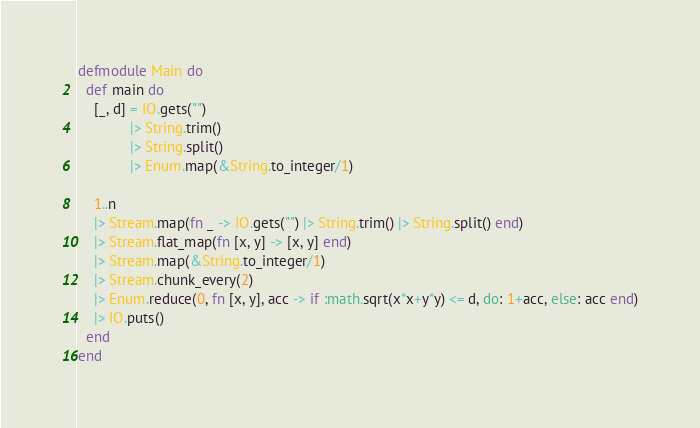<code> <loc_0><loc_0><loc_500><loc_500><_Elixir_>defmodule Main do
  def main do
    [_, d] = IO.gets("")
             |> String.trim()
             |> String.split()
             |> Enum.map(&String.to_integer/1)

    1..n
    |> Stream.map(fn _ -> IO.gets("") |> String.trim() |> String.split() end)
    |> Stream.flat_map(fn [x, y] -> [x, y] end)
    |> Stream.map(&String.to_integer/1)
    |> Stream.chunk_every(2)
    |> Enum.reduce(0, fn [x, y], acc -> if :math.sqrt(x*x+y*y) <= d, do: 1+acc, else: acc end)
    |> IO.puts()
  end
end
</code> 